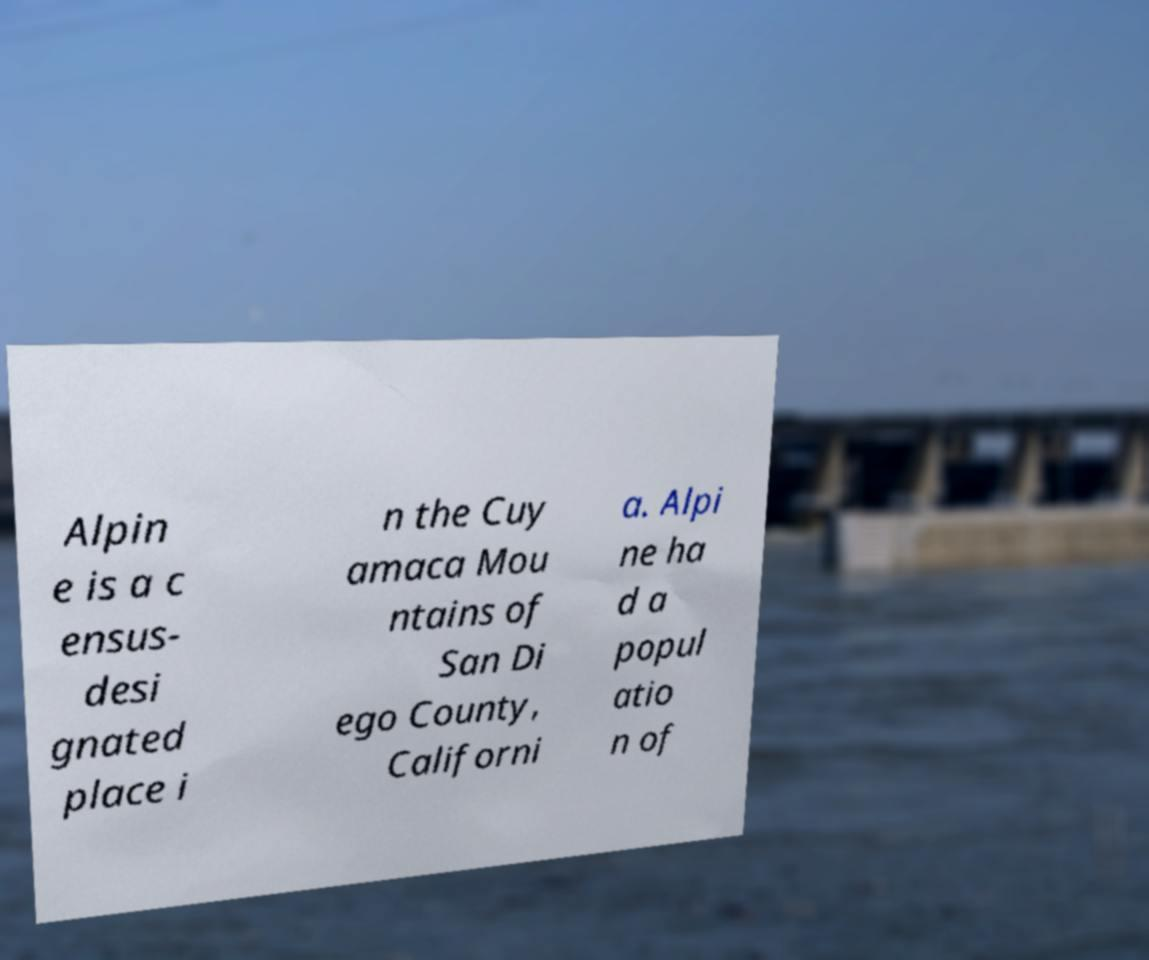There's text embedded in this image that I need extracted. Can you transcribe it verbatim? Alpin e is a c ensus- desi gnated place i n the Cuy amaca Mou ntains of San Di ego County, Californi a. Alpi ne ha d a popul atio n of 